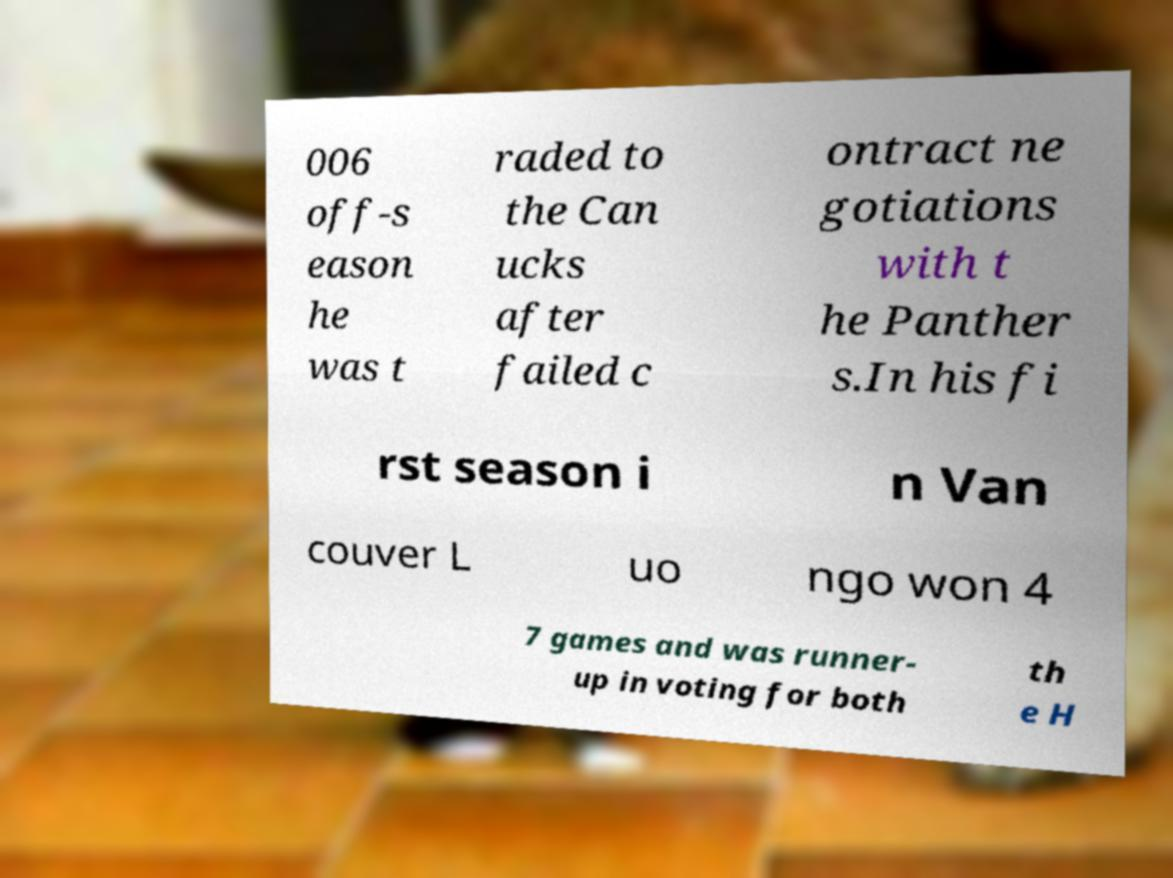For documentation purposes, I need the text within this image transcribed. Could you provide that? 006 off-s eason he was t raded to the Can ucks after failed c ontract ne gotiations with t he Panther s.In his fi rst season i n Van couver L uo ngo won 4 7 games and was runner- up in voting for both th e H 